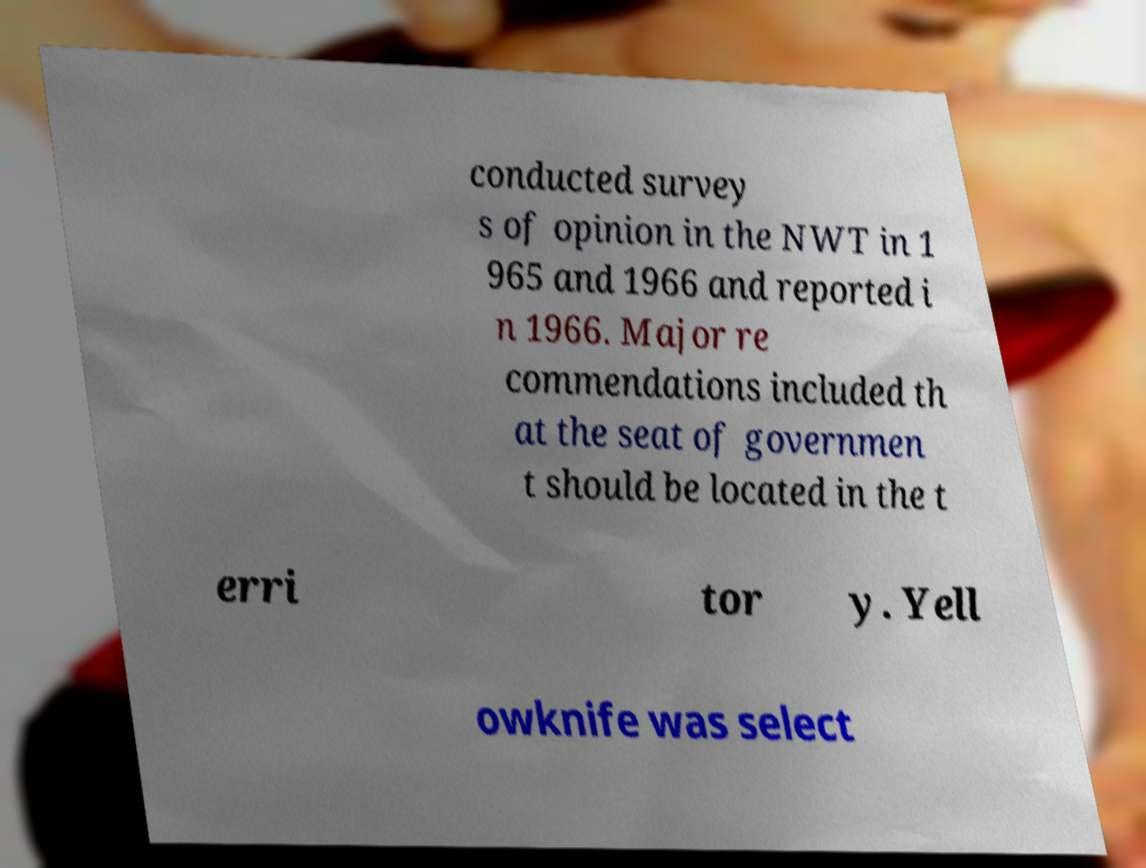Could you extract and type out the text from this image? conducted survey s of opinion in the NWT in 1 965 and 1966 and reported i n 1966. Major re commendations included th at the seat of governmen t should be located in the t erri tor y. Yell owknife was select 